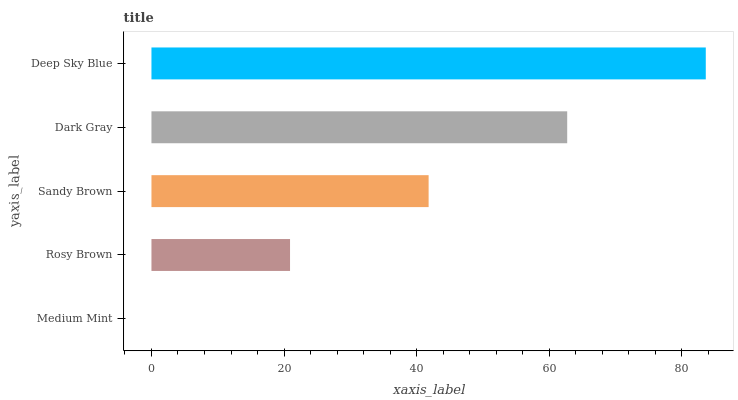Is Medium Mint the minimum?
Answer yes or no. Yes. Is Deep Sky Blue the maximum?
Answer yes or no. Yes. Is Rosy Brown the minimum?
Answer yes or no. No. Is Rosy Brown the maximum?
Answer yes or no. No. Is Rosy Brown greater than Medium Mint?
Answer yes or no. Yes. Is Medium Mint less than Rosy Brown?
Answer yes or no. Yes. Is Medium Mint greater than Rosy Brown?
Answer yes or no. No. Is Rosy Brown less than Medium Mint?
Answer yes or no. No. Is Sandy Brown the high median?
Answer yes or no. Yes. Is Sandy Brown the low median?
Answer yes or no. Yes. Is Rosy Brown the high median?
Answer yes or no. No. Is Deep Sky Blue the low median?
Answer yes or no. No. 